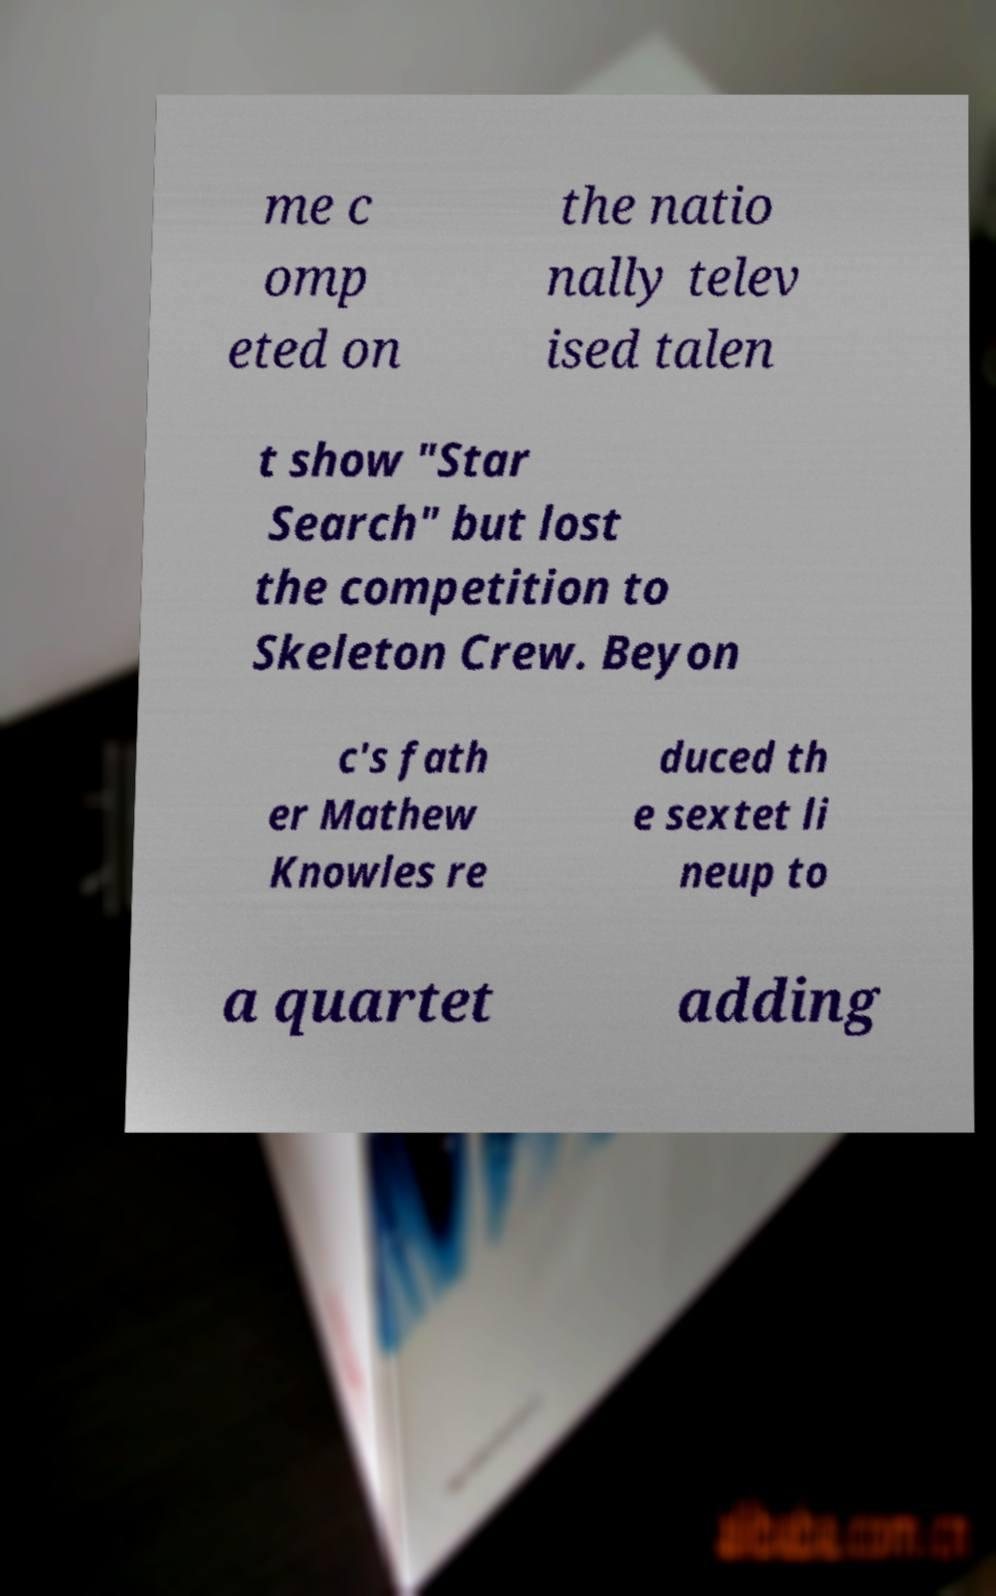Please read and relay the text visible in this image. What does it say? me c omp eted on the natio nally telev ised talen t show "Star Search" but lost the competition to Skeleton Crew. Beyon c's fath er Mathew Knowles re duced th e sextet li neup to a quartet adding 